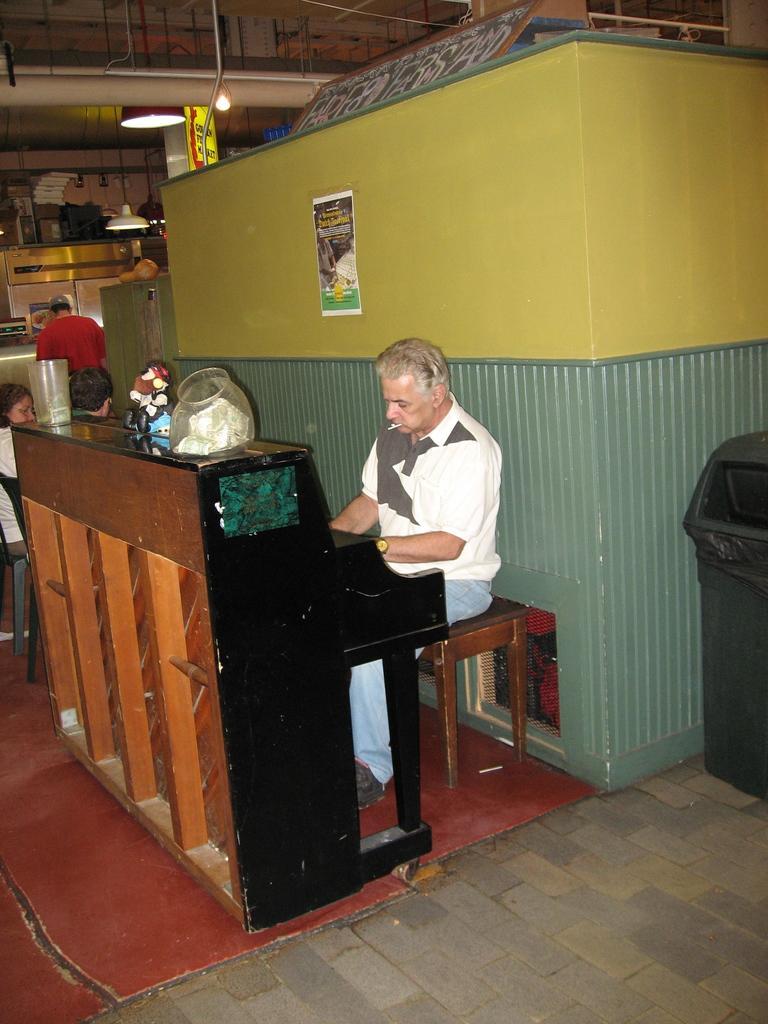Describe this image in one or two sentences. In this picture there is a man who is wearing shirt, torture, watch and shoes. He is sitting on the chair and a playing a piano. On that I can see some jar and flowers. On the left there is a girl who is sitting on the plastic chair. In the back there is a man who is standing near to the kitchen platform. At the top I can see some light, pipe and duct. On the right there is a dustbin which is placed near to the wall. 